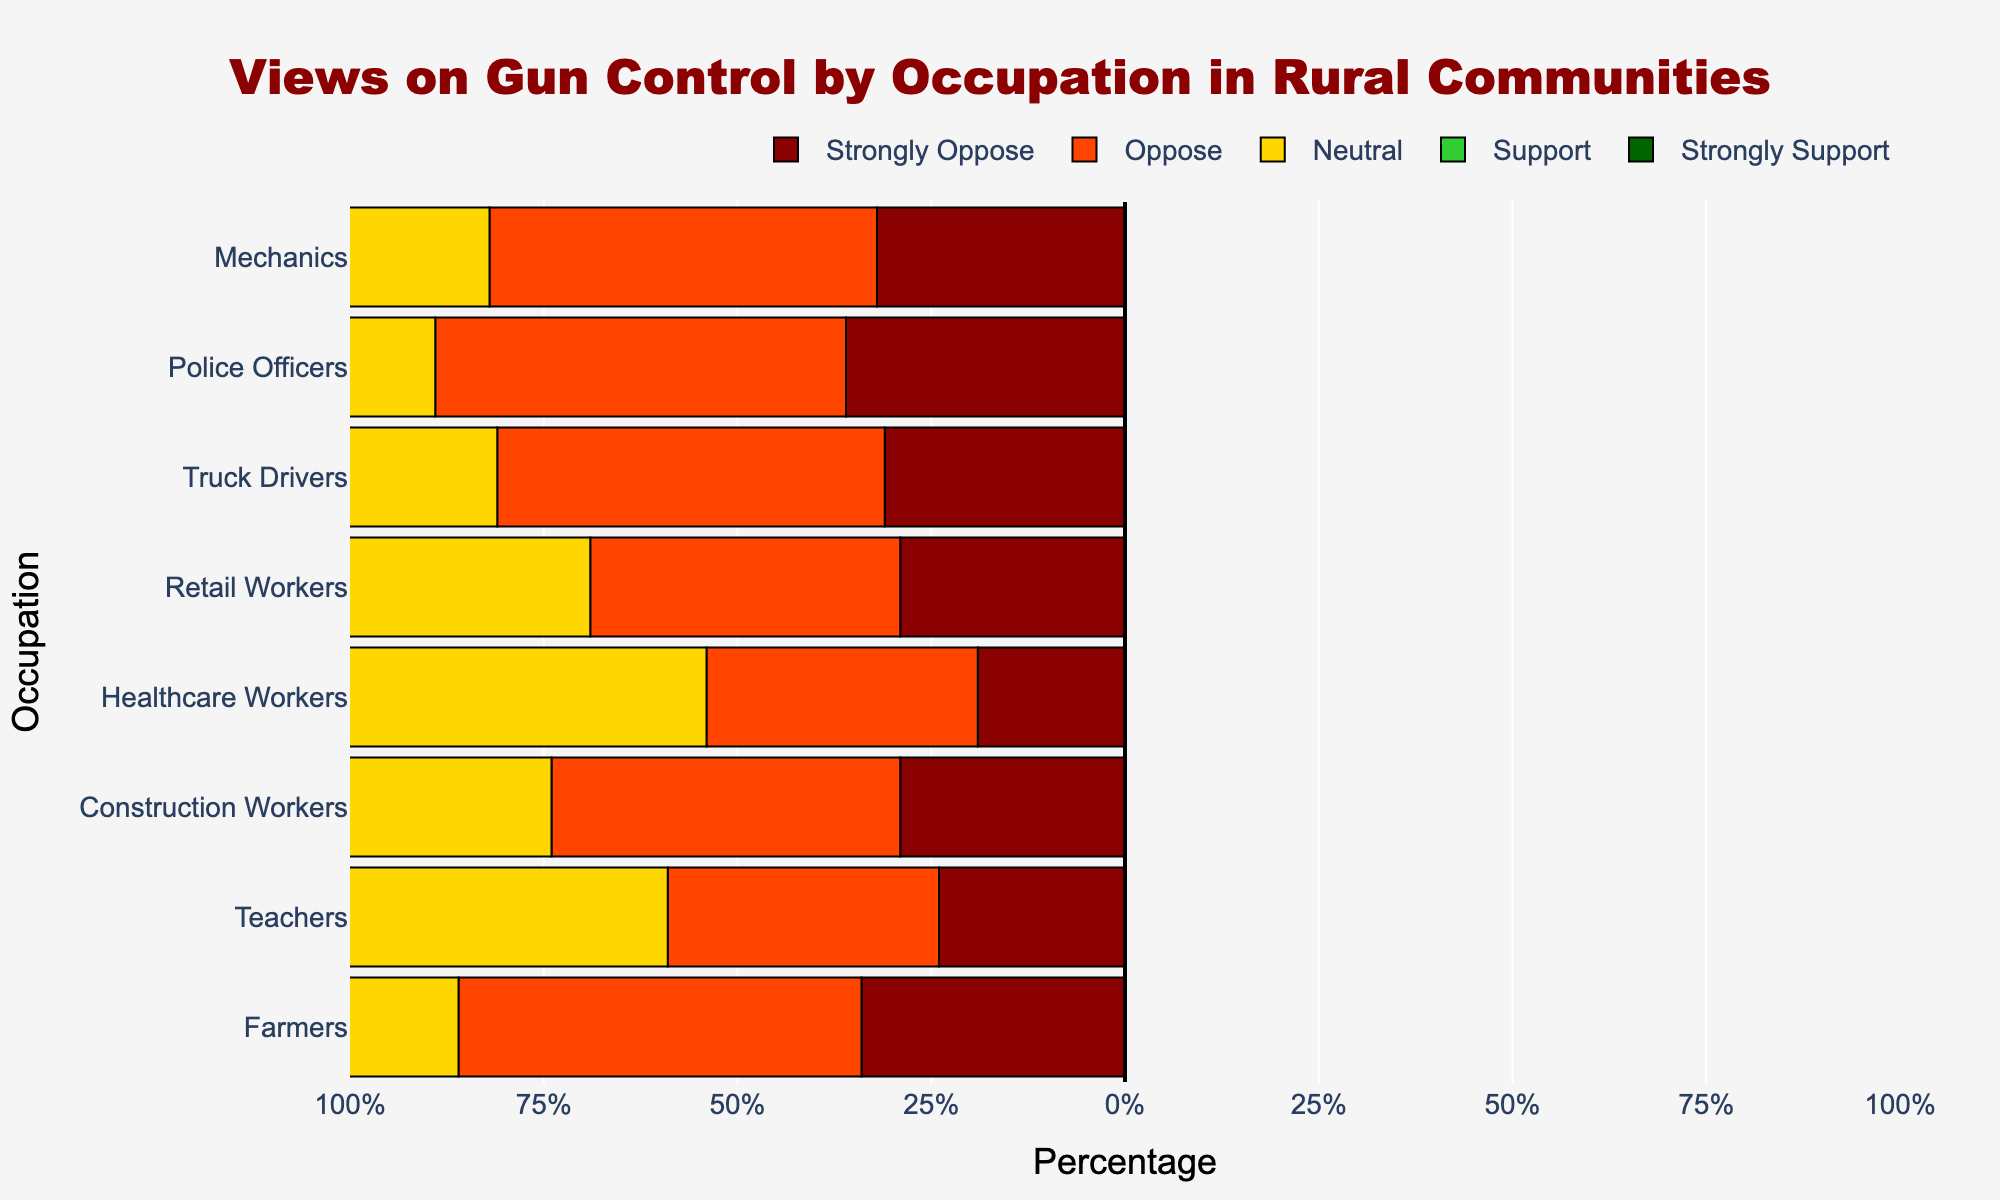Which occupation has the highest percentage of individuals who strongly support gun control? Police Officers have the highest percentage of individuals who strongly support gun control. To determine this, look for the highest bar in dark green (Strongly Support) and see which occupation it corresponds to.
Answer: Police Officers Which occupation has the least opposition to gun control (combining Strongly Oppose and Oppose)? Farmers have the least opposition to gun control. To determine this, calculate the sum of the Strongly Oppose and Oppose percentages for each occupation and find the lowest sum. For Farmers: 5 + 8 = 13%.
Answer: Farmers Compare the percentage of Farmers who support or strongly support gun control with that of Truck Drivers. Which occupation has a higher combined percentage? Farmers: 35% (Support) + 37% (Strongly Support) = 72%. Truck Drivers: 35% (Support) + 27% (Strongly Support) = 62%. Thus, Farmers have a higher combined percentage.
Answer: Farmers What is the difference in the percentage of Teachers who oppose gun control versus those who support it? Teachers who Oppose: 25%. Teachers who Support: 25%. The difference is zero since both percentages are equal.
Answer: 0% Which occupation shows the most neutral stance towards gun control? Healthcare Workers show the most neutral stance towards gun control. To find this, compare the length of the neutral (yellow) bars for each occupation. The longest bar is for Healthcare Workers.
Answer: Healthcare Workers For which occupation is the percentage of strong opposition (Strongly Oppose) closest to the percentage of strong support (Strongly Support)? For Retail Workers, the Strongly Oppose percentage is 10% and the Strongly Support percentage is 20%, giving a difference of 10%. This is the smallest difference compared to other occupations where these percentages significantly differ.
Answer: Retail Workers Which occupation has the smallest percentage of individuals who are neutral on gun control? Police Officers have the smallest percentage of neutral individuals. This is evident by comparing the length of the neutral (yellow) bar among all occupations.
Answer: Police Officers 